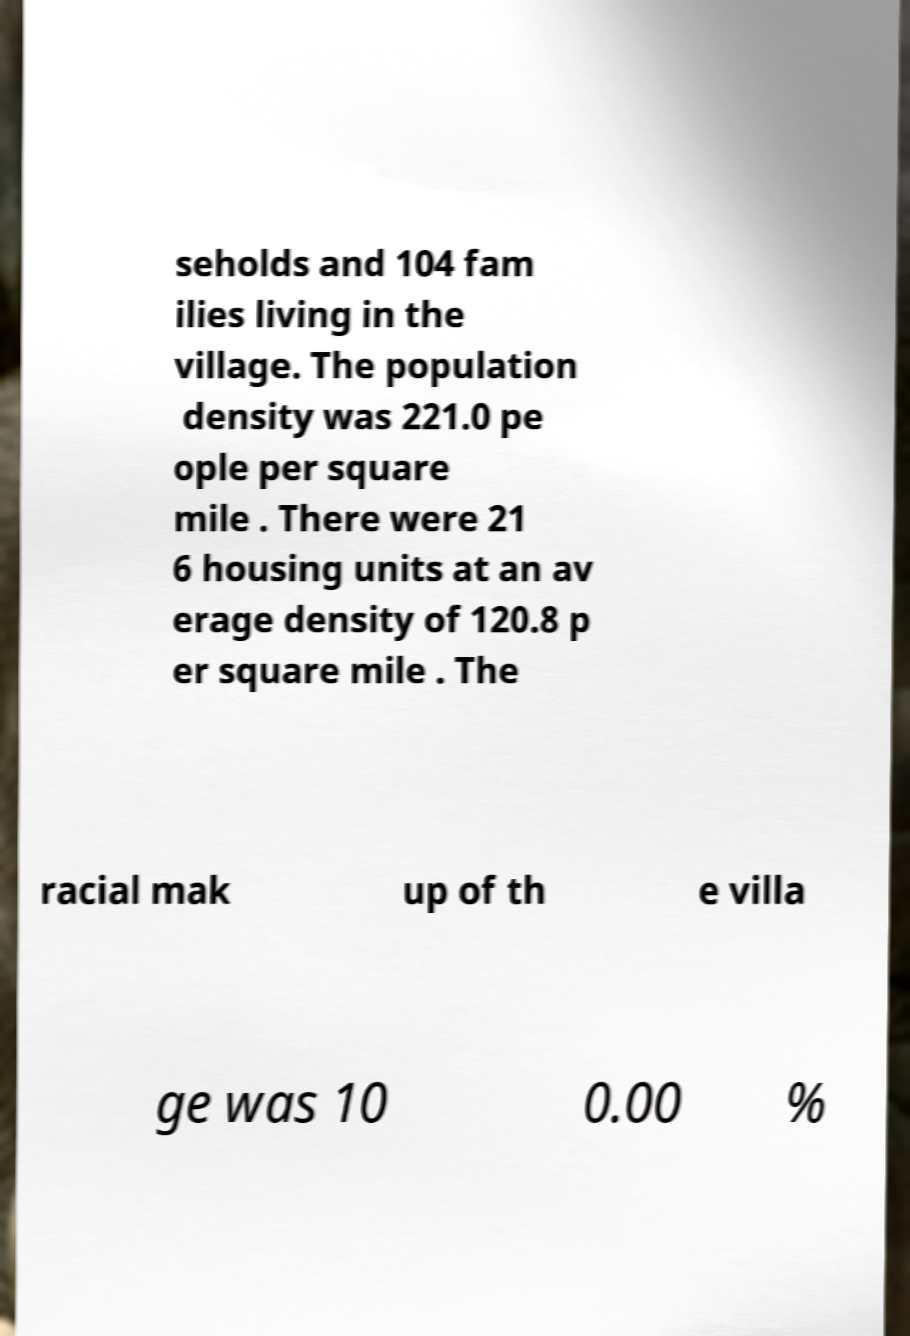Can you read and provide the text displayed in the image?This photo seems to have some interesting text. Can you extract and type it out for me? seholds and 104 fam ilies living in the village. The population density was 221.0 pe ople per square mile . There were 21 6 housing units at an av erage density of 120.8 p er square mile . The racial mak up of th e villa ge was 10 0.00 % 